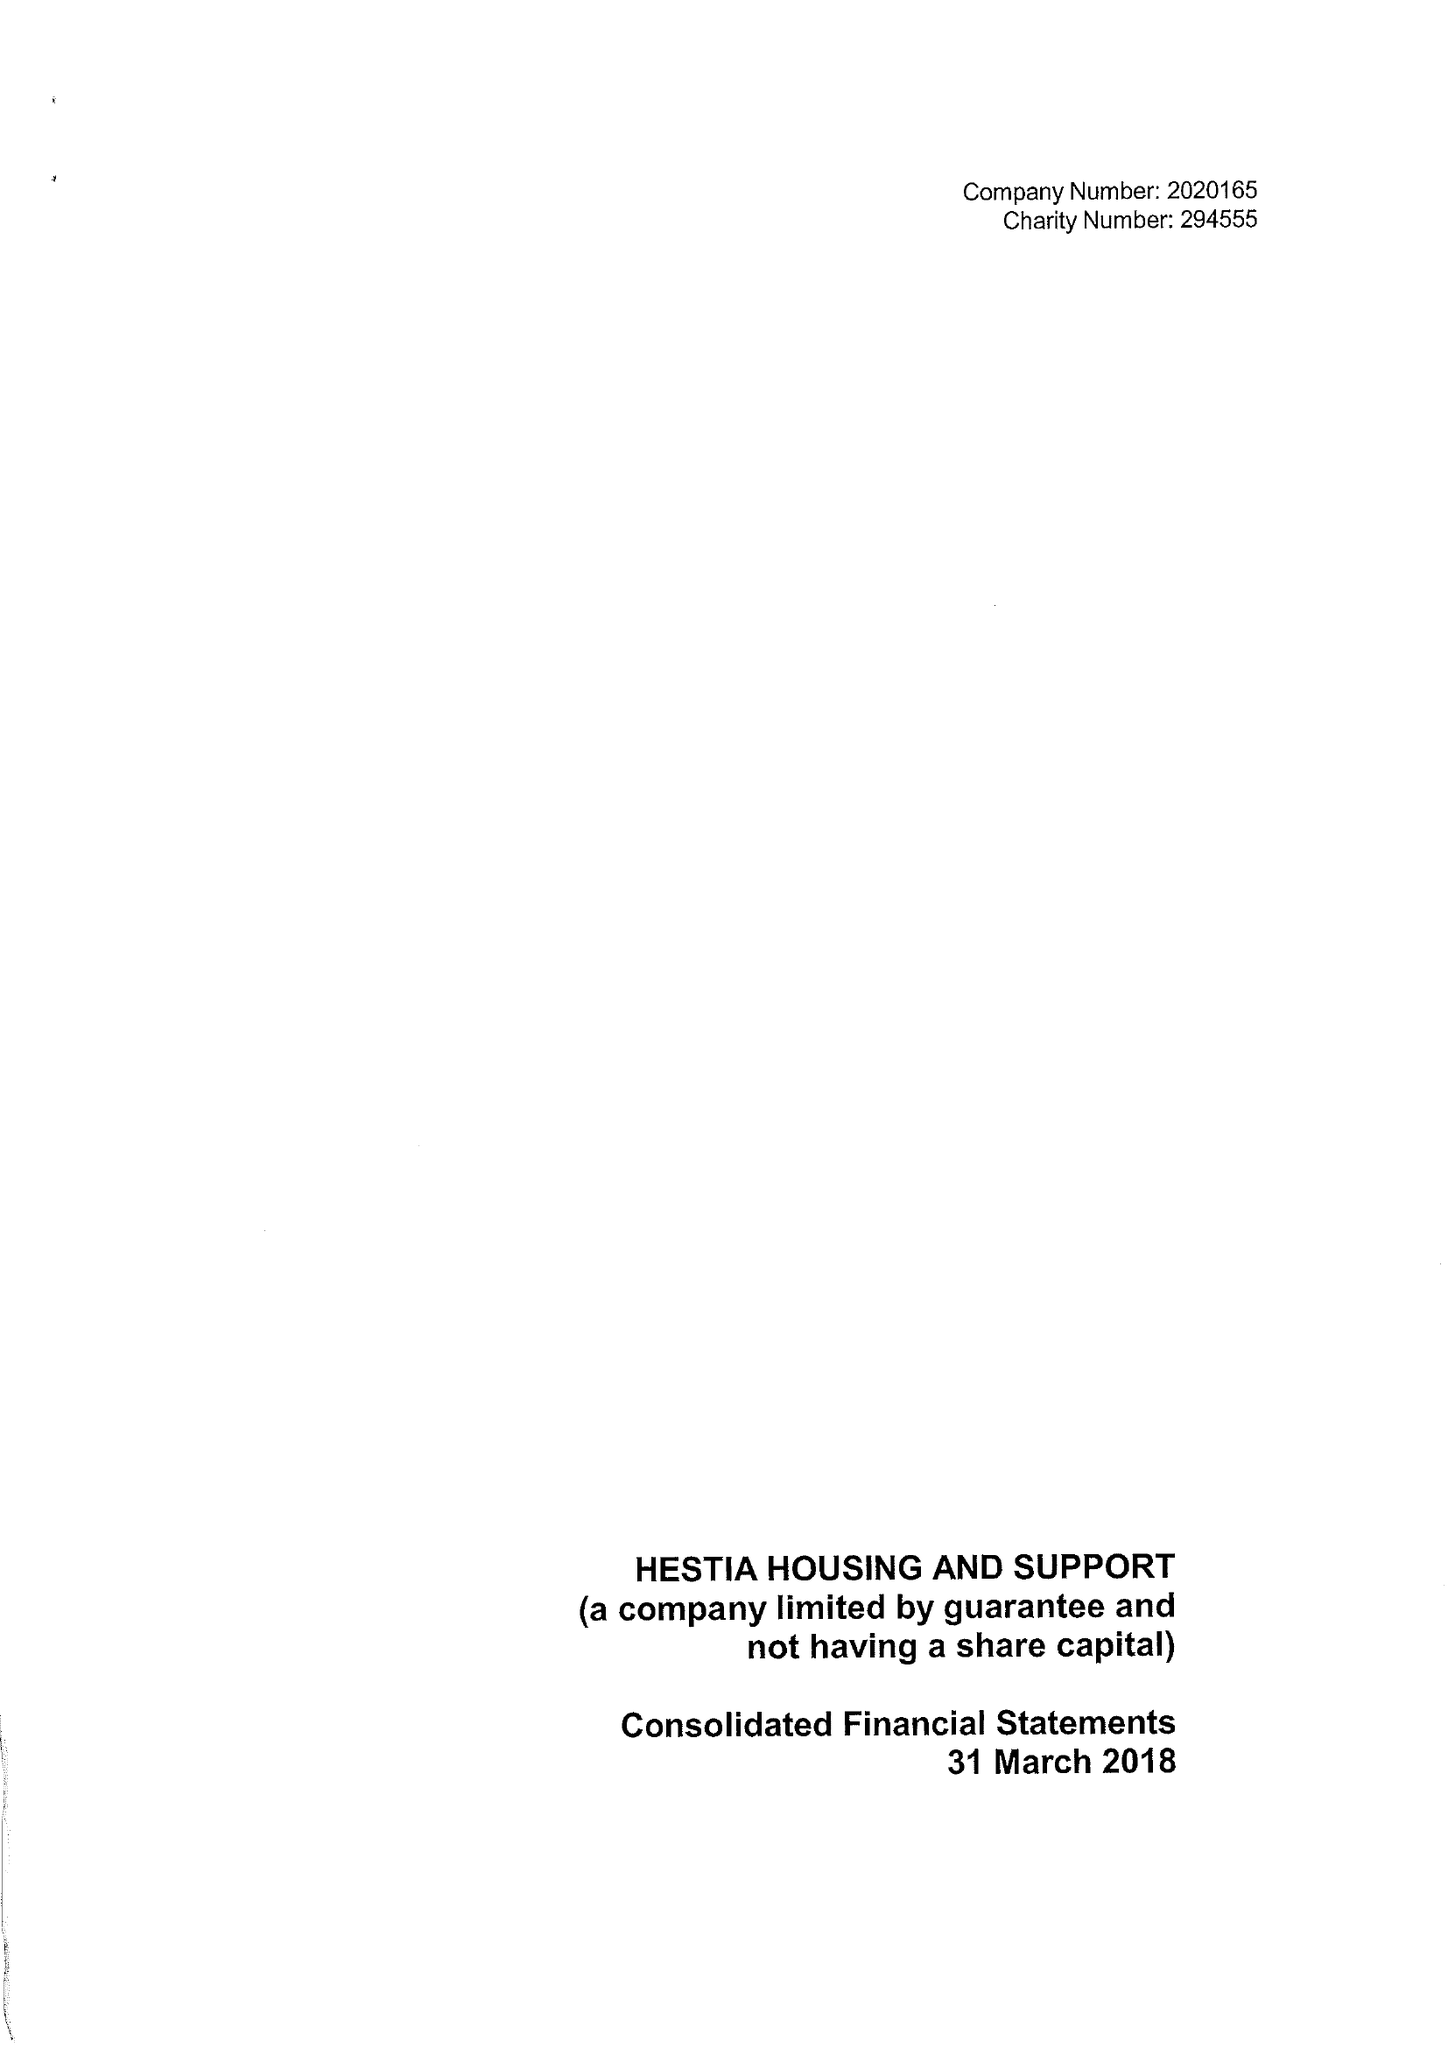What is the value for the report_date?
Answer the question using a single word or phrase. 2018-03-31 